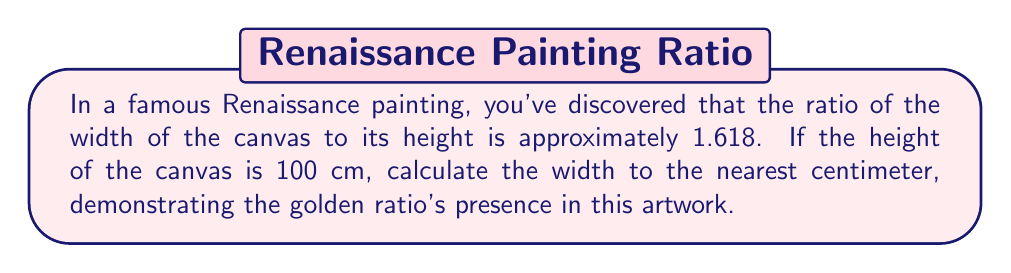Solve this math problem. Let's approach this step-by-step, embracing the juxtaposition of art and mathematics:

1) The golden ratio, denoted by φ (phi), is approximately 1.618.

2) We're given that the ratio of width to height is φ:
   $$ \frac{\text{width}}{\text{height}} \approx 1.618 $$

3) We know the height is 100 cm. Let's call the width x cm:
   $$ \frac{x}{100} \approx 1.618 $$

4) To solve for x, multiply both sides by 100:
   $$ x \approx 1.618 \times 100 $$

5) Calculate:
   $$ x \approx 161.8 \text{ cm} $$

6) Rounding to the nearest centimeter:
   $$ x \approx 162 \text{ cm} $$

This result beautifully illustrates how Renaissance artists often incorporated the golden ratio into their compositions, creating a harmonious balance that continues to captivate art historians and mathematicians alike.
Answer: 162 cm 